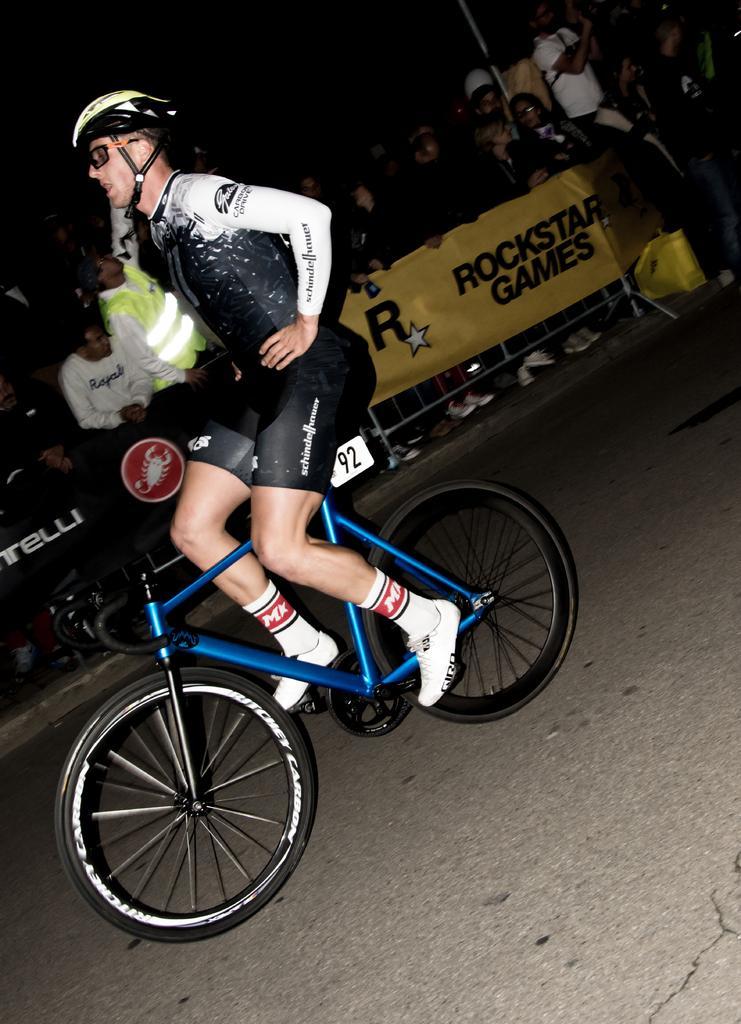Could you give a brief overview of what you see in this image? In the center of the image a man is sitting on a bicycle and wearing helmet, goggles. In the background of the image we can see a group of people, barricades, boards, bag. At the bottom of the image we can see the road. 